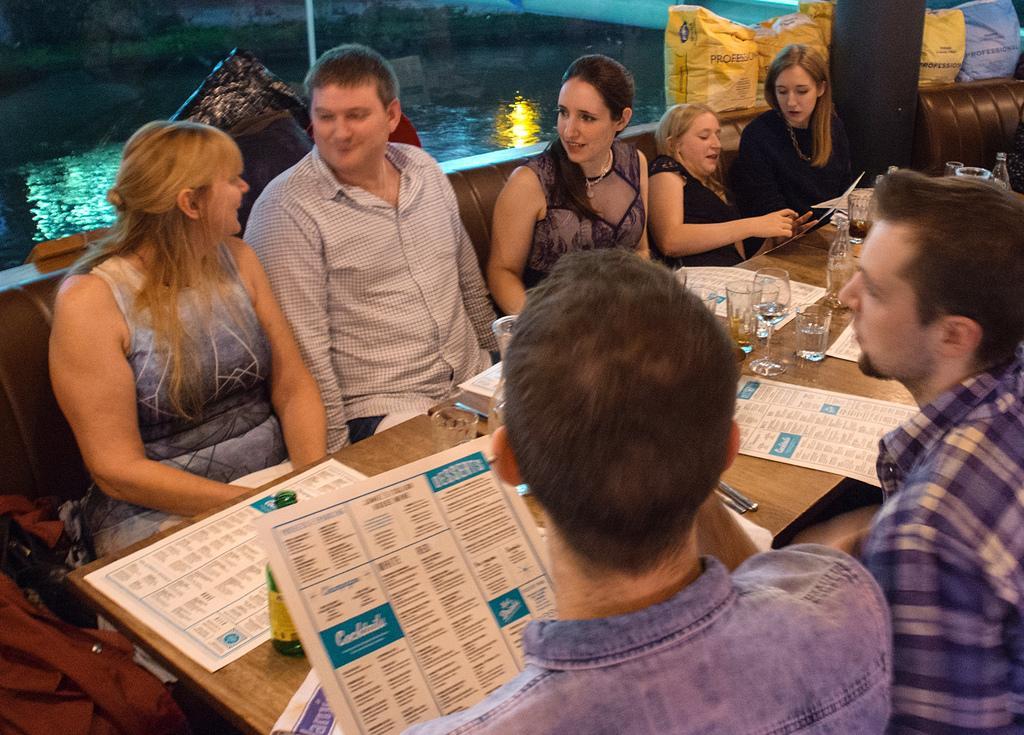In one or two sentences, can you explain what this image depicts? In this picture we can see some people are sitting in front of table, there are some glasses, cards and bottles on this table, we can see some text on these cards, in the background there is water, there are bags at the right top of the picture. 